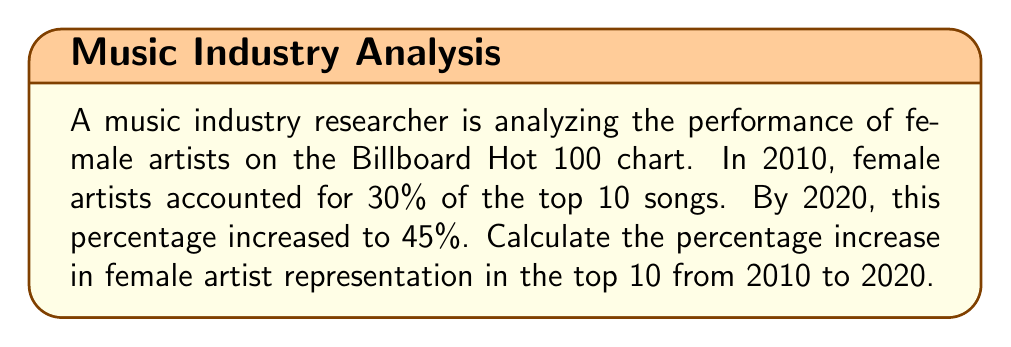What is the answer to this math problem? To calculate the percentage increase, we'll follow these steps:

1. Calculate the difference between the final and initial percentages:
   $$45\% - 30\% = 15\%$$

2. Divide this difference by the initial percentage:
   $$\frac{15\%}{30\%} = 0.5$$

3. Convert the result to a percentage by multiplying by 100:
   $$0.5 \times 100 = 50\%$$

The formula for percentage increase is:

$$\text{Percentage Increase} = \frac{\text{New Value} - \text{Original Value}}{\text{Original Value}} \times 100\%$$

Plugging in our values:

$$\text{Percentage Increase} = \frac{45\% - 30\%}{30\%} \times 100\% = \frac{15\%}{30\%} \times 100\% = 0.5 \times 100\% = 50\%$$

Therefore, the percentage increase in female artist representation in the top 10 from 2010 to 2020 is 50%.
Answer: 50% 